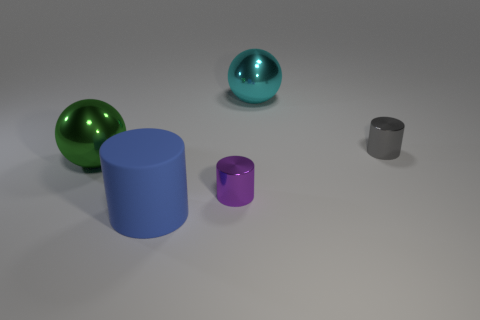What is the color of the rubber cylinder?
Make the answer very short. Blue. What number of other large matte cylinders are the same color as the matte cylinder?
Your answer should be compact. 0. There is a purple shiny object; are there any purple cylinders on the right side of it?
Your response must be concise. No. Is the number of blue rubber things that are right of the blue rubber cylinder the same as the number of tiny things that are behind the cyan shiny thing?
Give a very brief answer. Yes. There is a object left of the rubber cylinder; does it have the same size as the shiny cylinder that is on the right side of the purple shiny cylinder?
Offer a terse response. No. There is a big thing that is on the left side of the blue thing that is in front of the metal ball to the left of the big blue matte thing; what shape is it?
Provide a succinct answer. Sphere. Are there any other things that have the same material as the large green thing?
Keep it short and to the point. Yes. The purple object that is the same shape as the blue rubber object is what size?
Your answer should be compact. Small. There is a thing that is both behind the green metallic thing and left of the gray cylinder; what color is it?
Give a very brief answer. Cyan. Does the cyan object have the same material as the sphere in front of the small gray metal cylinder?
Offer a very short reply. Yes. 